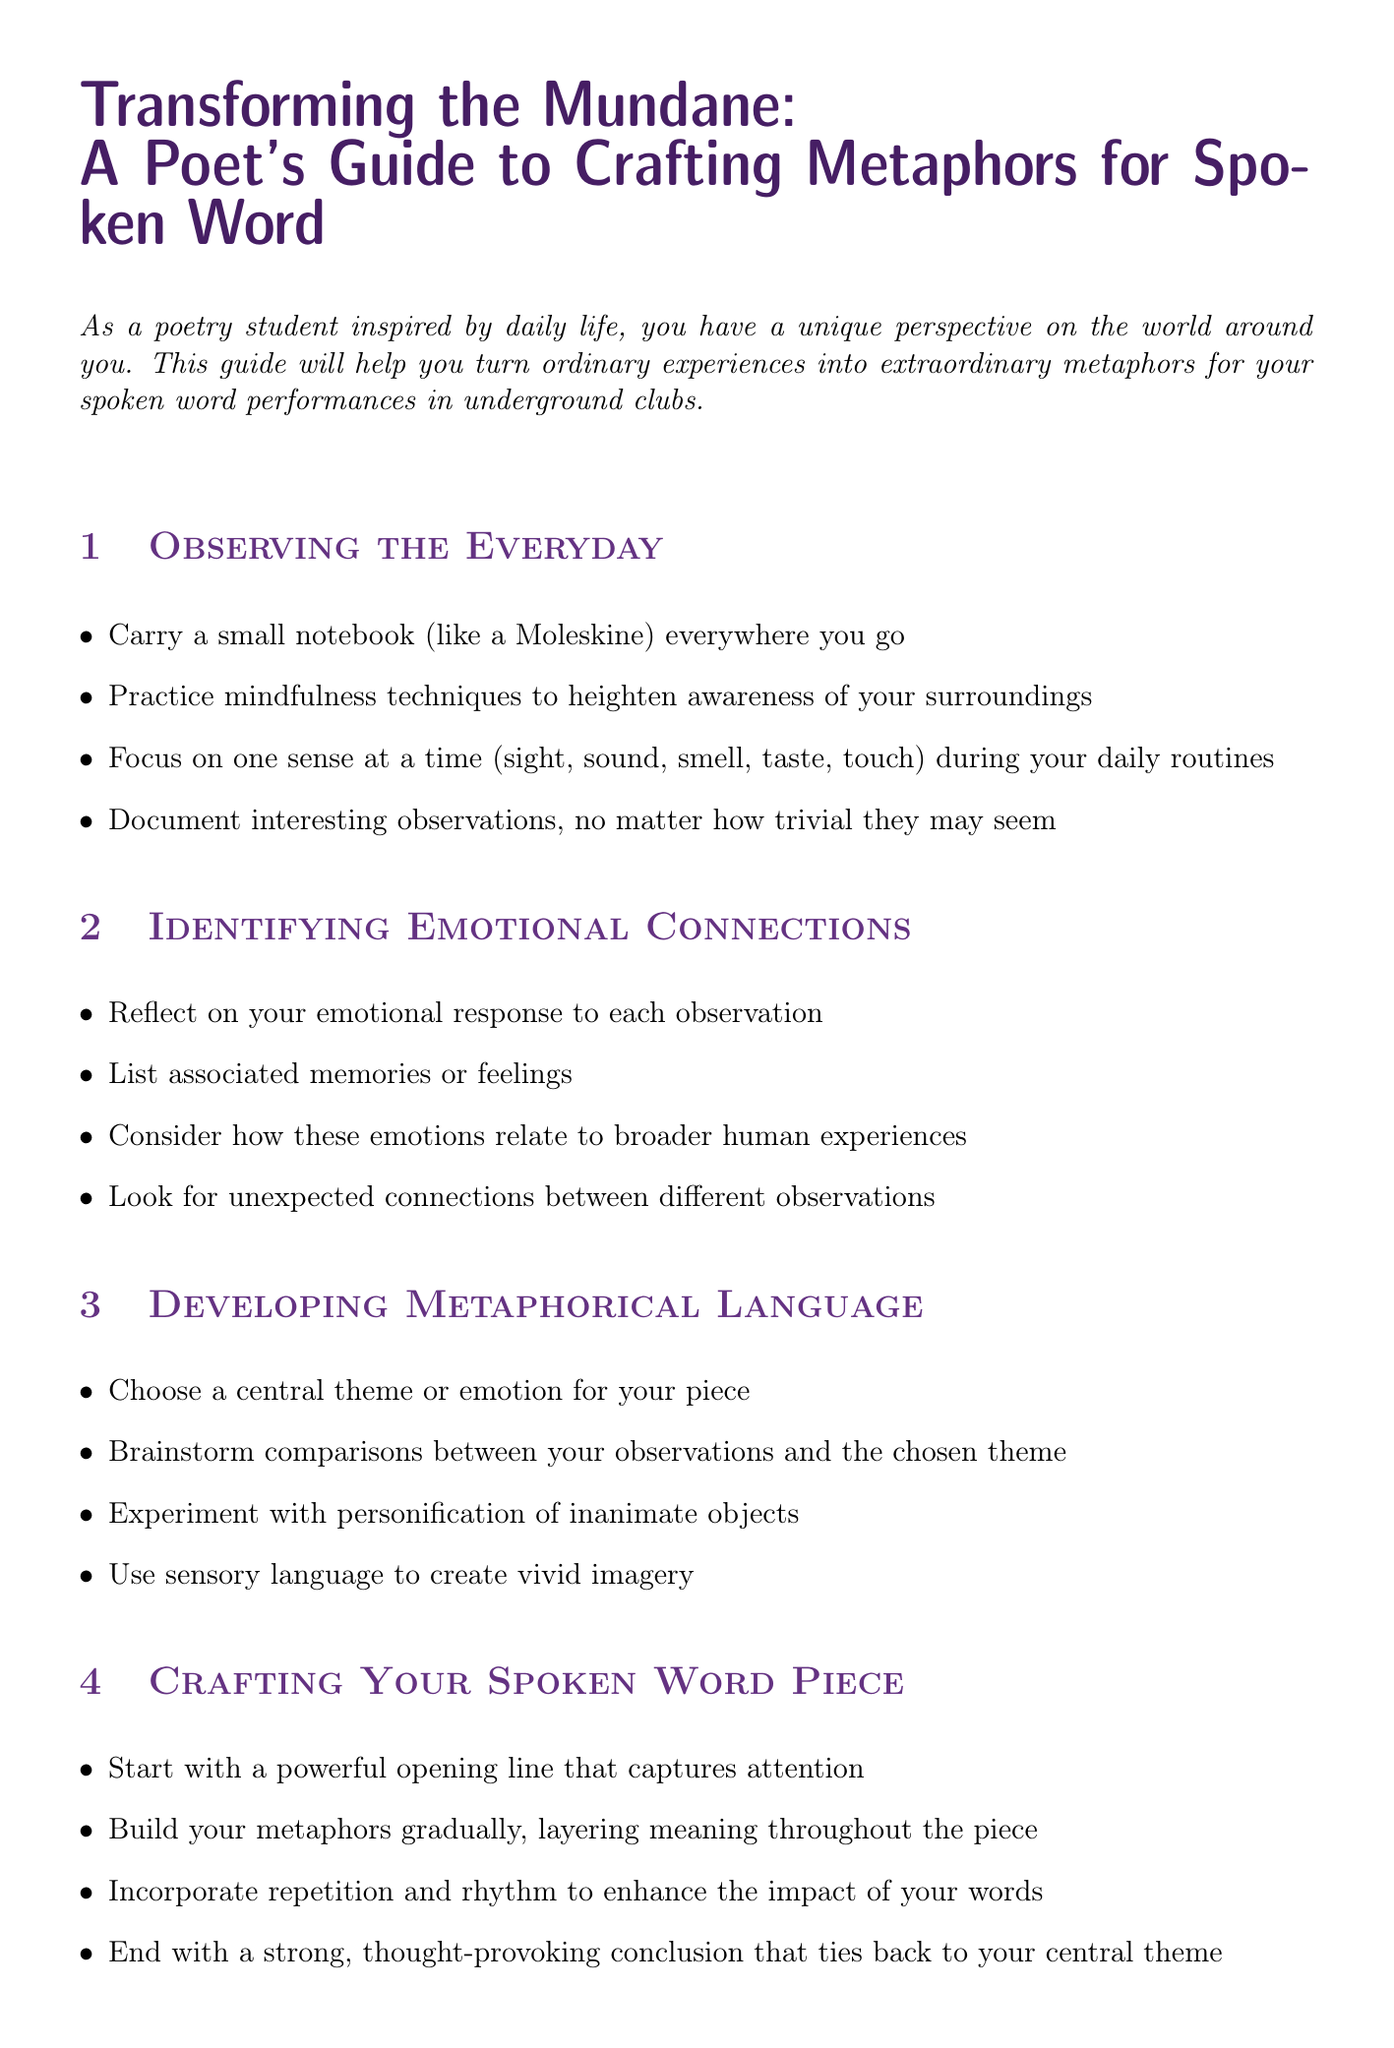What is the title of the guide? The title is clearly stated at the beginning of the document and is "Transforming the Mundane: A Poet's Guide to Crafting Metaphors for Spoken Word."
Answer: Transforming the Mundane: A Poet's Guide to Crafting Metaphors for Spoken Word Who are the authors mentioned in the resources? The authors of the recommended resource "The Poet's Companion" are provided in the document.
Answer: Kim Addonizio and Dorianne Laux What is the first step in "Observing the Everyday"? The first step listed in this section is to carry a small notebook everywhere you go.
Answer: Carry a small notebook (like a Moleskine) everywhere you go How many steps are included in the "Refining for Performance" section? The section includes detailed steps about performance and their count is mentioned.
Answer: Four What metaphor is used for "Walking through a crowded street"? The document provides a specific metaphor for this mundane experience.
Answer: A river of humanity, each person a drop in the current, carrying stories like sediment, eroding the bedrock of solitude What is the purpose of the guide? The introduction summarizes the main purpose of the guide effectively.
Answer: To help you turn ordinary experiences into extraordinary metaphors Which resource offers a collection of spoken word performances? The resources section lists various references, and one specifically mentions spoken word performances.
Answer: Button Poetry YouTube Channel What type of language does the "Developing Metaphorical Language" section encourage using? The steps suggest a particular style of language that enhances poetic creativity.
Answer: Sensory language What should you do at the end of your spoken word piece? The crafting section advises on how to conclude your piece effectively.
Answer: End with a strong, thought-provoking conclusion that ties back to your central theme 